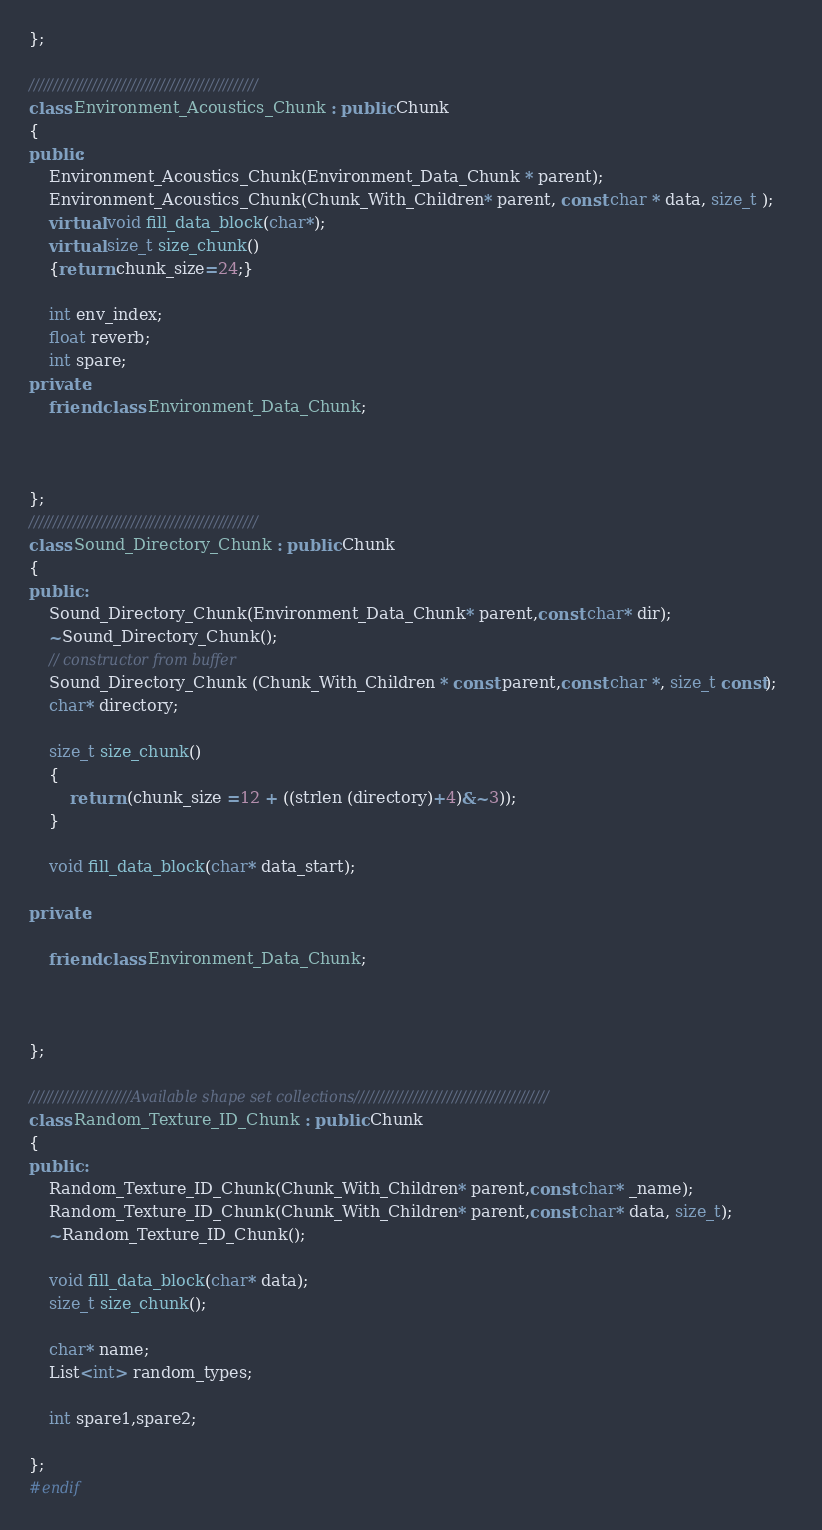<code> <loc_0><loc_0><loc_500><loc_500><_C++_>};

///////////////////////////////////////////////
class Environment_Acoustics_Chunk : public Chunk
{
public:
	Environment_Acoustics_Chunk(Environment_Data_Chunk * parent);
	Environment_Acoustics_Chunk(Chunk_With_Children* parent, const char * data, size_t );	
	virtual void fill_data_block(char*);
	virtual size_t size_chunk()
	{return chunk_size=24;}

	int env_index; 
	float reverb;
	int spare;
private:
	friend class Environment_Data_Chunk;
	


};
///////////////////////////////////////////////
class Sound_Directory_Chunk : public Chunk
{
public :
	Sound_Directory_Chunk(Environment_Data_Chunk* parent,const char* dir);
	~Sound_Directory_Chunk();
	// constructor from buffer
	Sound_Directory_Chunk (Chunk_With_Children * const parent,const char *, size_t const);
	char* directory;

	size_t size_chunk()
	{
		return (chunk_size =12 + ((strlen (directory)+4)&~3));
	}

	void fill_data_block(char* data_start);

private:

	friend class Environment_Data_Chunk;



};

/////////////////////Available shape set collections////////////////////////////////////////
class Random_Texture_ID_Chunk : public Chunk
{
public :
	Random_Texture_ID_Chunk(Chunk_With_Children* parent,const char* _name);
	Random_Texture_ID_Chunk(Chunk_With_Children* parent,const char* data, size_t);
	~Random_Texture_ID_Chunk();

	void fill_data_block(char* data);
	size_t size_chunk();

	char* name;
	List<int> random_types;
	
	int spare1,spare2;

};
#endif</code> 